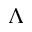Convert formula to latex. <formula><loc_0><loc_0><loc_500><loc_500>\Lambda</formula> 